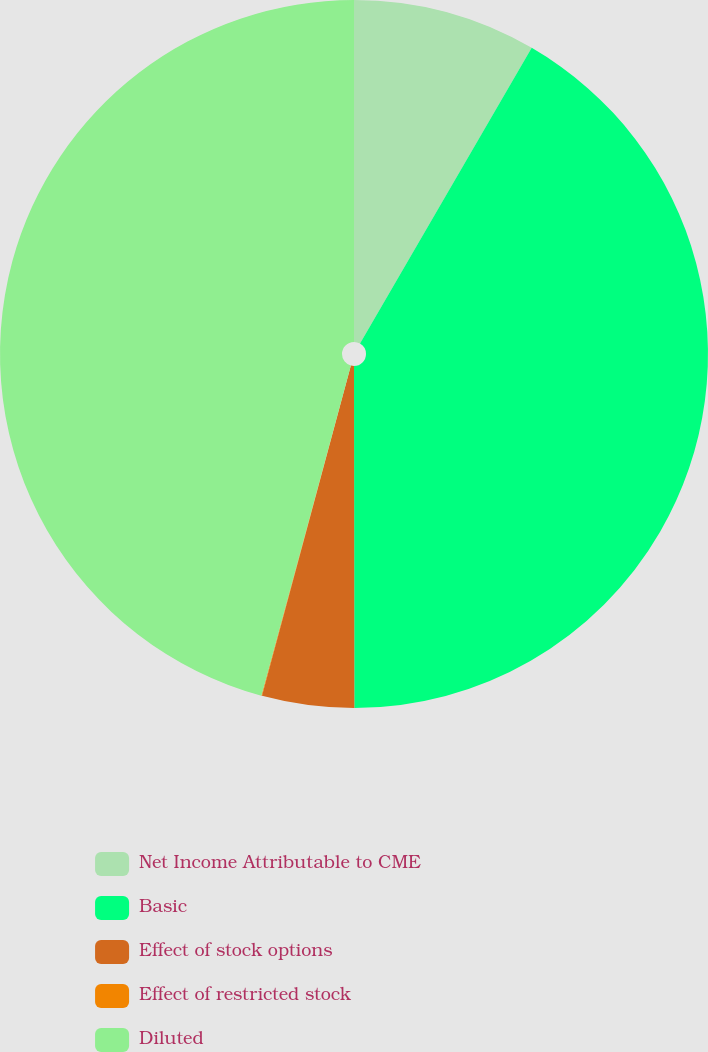Convert chart. <chart><loc_0><loc_0><loc_500><loc_500><pie_chart><fcel>Net Income Attributable to CME<fcel>Basic<fcel>Effect of stock options<fcel>Effect of restricted stock<fcel>Diluted<nl><fcel>8.37%<fcel>41.61%<fcel>4.2%<fcel>0.03%<fcel>45.78%<nl></chart> 